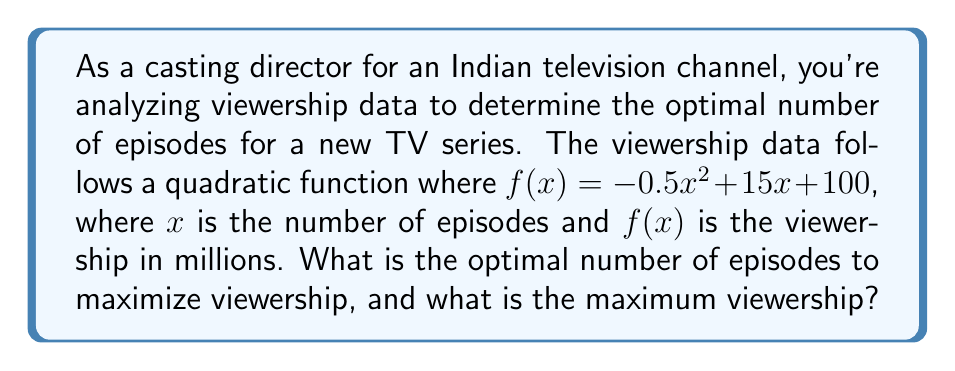Can you solve this math problem? To solve this problem, we need to follow these steps:

1) The viewership function is given as:
   $$f(x) = -0.5x^2 + 15x + 100$$

2) To find the maximum viewership, we need to find the vertex of this parabola. The vertex represents the point where the function reaches its maximum value.

3) For a quadratic function in the form $f(x) = ax^2 + bx + c$, the x-coordinate of the vertex is given by:
   $$x = -\frac{b}{2a}$$

4) In our case, $a = -0.5$ and $b = 15$. Let's substitute these values:
   $$x = -\frac{15}{2(-0.5)} = -\frac{15}{-1} = 15$$

5) This means the optimal number of episodes is 15.

6) To find the maximum viewership, we need to calculate $f(15)$:
   $$f(15) = -0.5(15)^2 + 15(15) + 100$$
   $$= -0.5(225) + 225 + 100$$
   $$= -112.5 + 225 + 100$$
   $$= 212.5$$

Therefore, the maximum viewership is 212.5 million viewers.
Answer: The optimal number of episodes is 15, and the maximum viewership is 212.5 million viewers. 